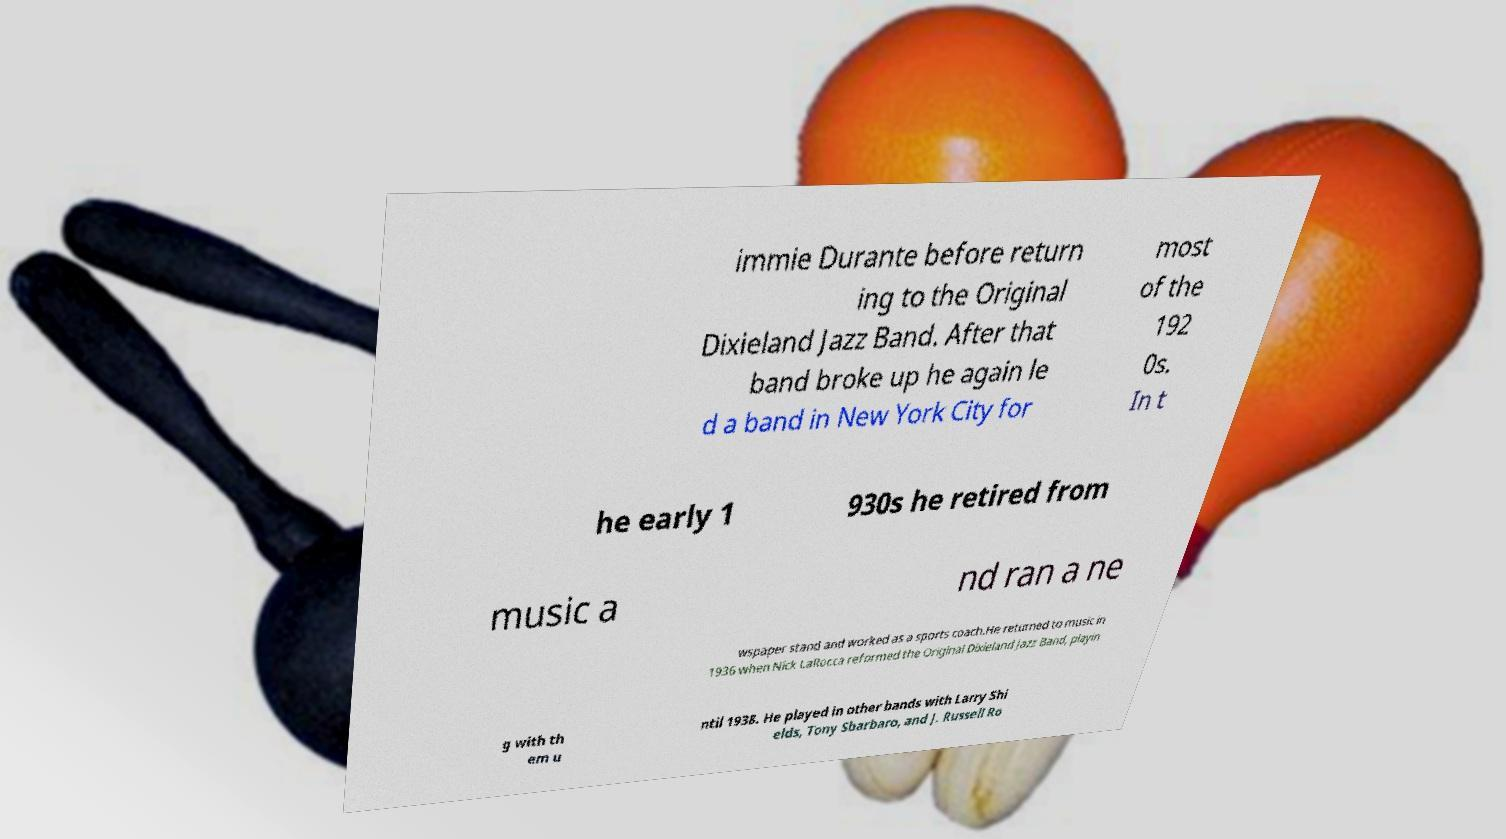There's text embedded in this image that I need extracted. Can you transcribe it verbatim? immie Durante before return ing to the Original Dixieland Jazz Band. After that band broke up he again le d a band in New York City for most of the 192 0s. In t he early 1 930s he retired from music a nd ran a ne wspaper stand and worked as a sports coach.He returned to music in 1936 when Nick LaRocca reformed the Original Dixieland Jazz Band, playin g with th em u ntil 1938. He played in other bands with Larry Shi elds, Tony Sbarbaro, and J. Russell Ro 